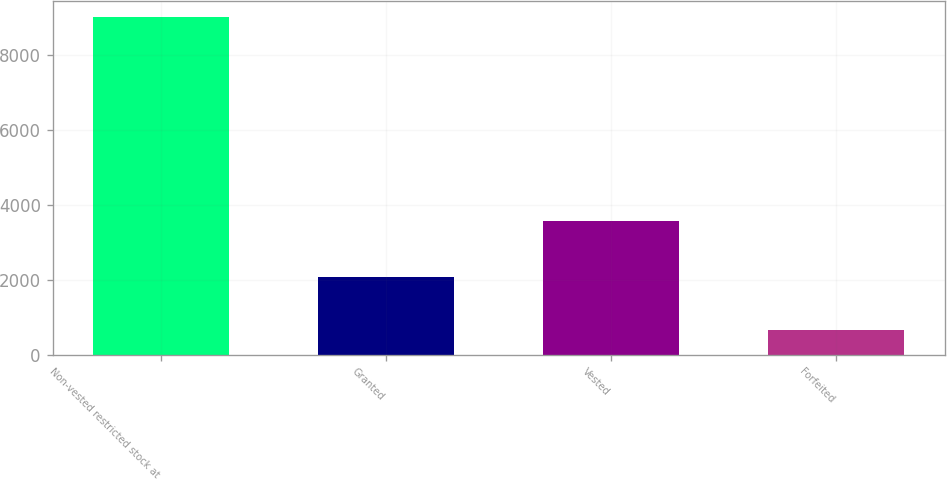Convert chart to OTSL. <chart><loc_0><loc_0><loc_500><loc_500><bar_chart><fcel>Non-vested restricted stock at<fcel>Granted<fcel>Vested<fcel>Forfeited<nl><fcel>8995<fcel>2090<fcel>3576<fcel>674<nl></chart> 